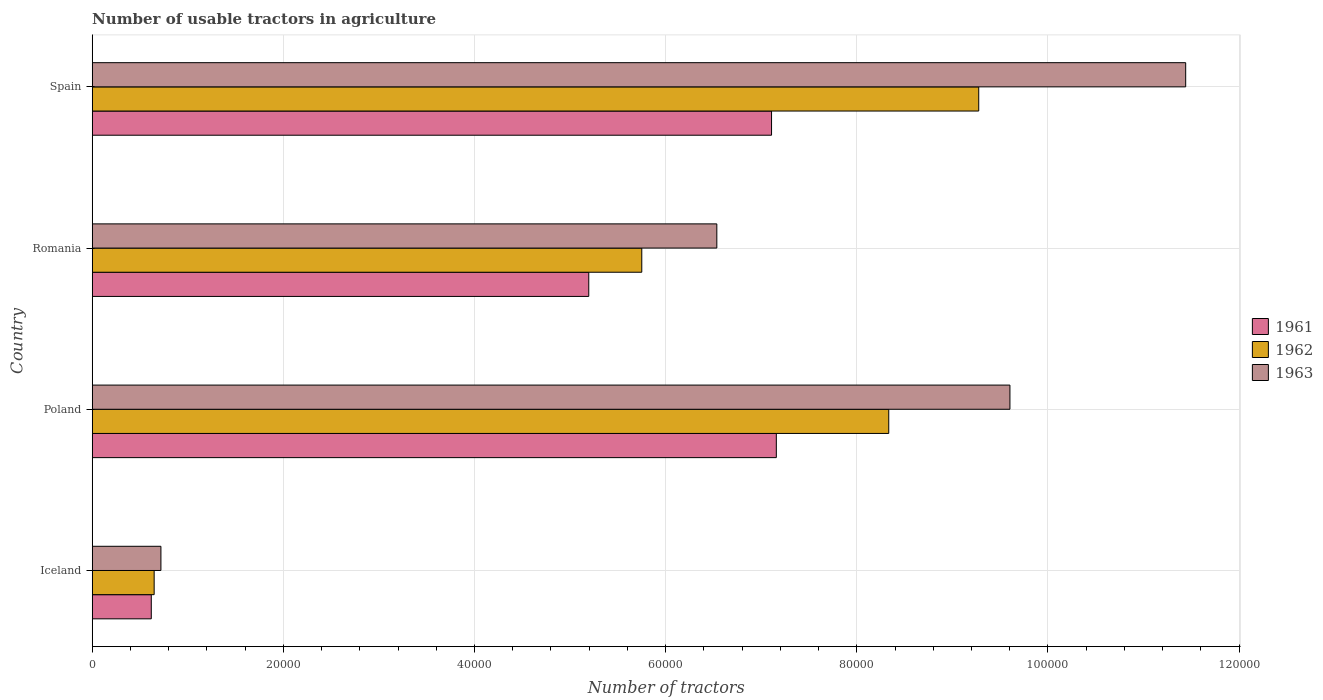Are the number of bars per tick equal to the number of legend labels?
Keep it short and to the point. Yes. How many bars are there on the 4th tick from the bottom?
Your answer should be compact. 3. What is the label of the 4th group of bars from the top?
Give a very brief answer. Iceland. What is the number of usable tractors in agriculture in 1961 in Poland?
Your answer should be very brief. 7.16e+04. Across all countries, what is the maximum number of usable tractors in agriculture in 1961?
Make the answer very short. 7.16e+04. Across all countries, what is the minimum number of usable tractors in agriculture in 1963?
Offer a terse response. 7187. In which country was the number of usable tractors in agriculture in 1961 maximum?
Provide a succinct answer. Poland. What is the total number of usable tractors in agriculture in 1963 in the graph?
Provide a succinct answer. 2.83e+05. What is the difference between the number of usable tractors in agriculture in 1963 in Iceland and that in Poland?
Ensure brevity in your answer.  -8.88e+04. What is the difference between the number of usable tractors in agriculture in 1961 in Romania and the number of usable tractors in agriculture in 1962 in Spain?
Keep it short and to the point. -4.08e+04. What is the average number of usable tractors in agriculture in 1961 per country?
Keep it short and to the point. 5.02e+04. What is the difference between the number of usable tractors in agriculture in 1961 and number of usable tractors in agriculture in 1963 in Romania?
Your answer should be compact. -1.34e+04. What is the ratio of the number of usable tractors in agriculture in 1961 in Poland to that in Spain?
Your response must be concise. 1.01. Is the number of usable tractors in agriculture in 1962 in Romania less than that in Spain?
Make the answer very short. Yes. What is the difference between the highest and the second highest number of usable tractors in agriculture in 1963?
Your answer should be very brief. 1.84e+04. What is the difference between the highest and the lowest number of usable tractors in agriculture in 1961?
Keep it short and to the point. 6.54e+04. Is the sum of the number of usable tractors in agriculture in 1962 in Iceland and Romania greater than the maximum number of usable tractors in agriculture in 1963 across all countries?
Keep it short and to the point. No. What does the 3rd bar from the top in Poland represents?
Your answer should be very brief. 1961. What does the 3rd bar from the bottom in Spain represents?
Provide a succinct answer. 1963. Are all the bars in the graph horizontal?
Offer a very short reply. Yes. How many countries are there in the graph?
Offer a very short reply. 4. What is the difference between two consecutive major ticks on the X-axis?
Provide a short and direct response. 2.00e+04. Are the values on the major ticks of X-axis written in scientific E-notation?
Provide a short and direct response. No. Does the graph contain any zero values?
Keep it short and to the point. No. Does the graph contain grids?
Ensure brevity in your answer.  Yes. How many legend labels are there?
Keep it short and to the point. 3. What is the title of the graph?
Your answer should be very brief. Number of usable tractors in agriculture. Does "1998" appear as one of the legend labels in the graph?
Make the answer very short. No. What is the label or title of the X-axis?
Ensure brevity in your answer.  Number of tractors. What is the Number of tractors in 1961 in Iceland?
Provide a succinct answer. 6177. What is the Number of tractors of 1962 in Iceland?
Ensure brevity in your answer.  6479. What is the Number of tractors of 1963 in Iceland?
Keep it short and to the point. 7187. What is the Number of tractors in 1961 in Poland?
Provide a short and direct response. 7.16e+04. What is the Number of tractors in 1962 in Poland?
Ensure brevity in your answer.  8.33e+04. What is the Number of tractors in 1963 in Poland?
Provide a succinct answer. 9.60e+04. What is the Number of tractors in 1961 in Romania?
Your answer should be compact. 5.20e+04. What is the Number of tractors in 1962 in Romania?
Keep it short and to the point. 5.75e+04. What is the Number of tractors in 1963 in Romania?
Offer a very short reply. 6.54e+04. What is the Number of tractors of 1961 in Spain?
Keep it short and to the point. 7.11e+04. What is the Number of tractors in 1962 in Spain?
Ensure brevity in your answer.  9.28e+04. What is the Number of tractors in 1963 in Spain?
Provide a short and direct response. 1.14e+05. Across all countries, what is the maximum Number of tractors of 1961?
Offer a terse response. 7.16e+04. Across all countries, what is the maximum Number of tractors of 1962?
Your response must be concise. 9.28e+04. Across all countries, what is the maximum Number of tractors in 1963?
Your answer should be very brief. 1.14e+05. Across all countries, what is the minimum Number of tractors of 1961?
Your response must be concise. 6177. Across all countries, what is the minimum Number of tractors of 1962?
Provide a succinct answer. 6479. Across all countries, what is the minimum Number of tractors in 1963?
Keep it short and to the point. 7187. What is the total Number of tractors in 1961 in the graph?
Your answer should be compact. 2.01e+05. What is the total Number of tractors of 1962 in the graph?
Provide a short and direct response. 2.40e+05. What is the total Number of tractors in 1963 in the graph?
Your response must be concise. 2.83e+05. What is the difference between the Number of tractors of 1961 in Iceland and that in Poland?
Offer a terse response. -6.54e+04. What is the difference between the Number of tractors in 1962 in Iceland and that in Poland?
Your answer should be compact. -7.69e+04. What is the difference between the Number of tractors in 1963 in Iceland and that in Poland?
Ensure brevity in your answer.  -8.88e+04. What is the difference between the Number of tractors of 1961 in Iceland and that in Romania?
Ensure brevity in your answer.  -4.58e+04. What is the difference between the Number of tractors in 1962 in Iceland and that in Romania?
Offer a terse response. -5.10e+04. What is the difference between the Number of tractors in 1963 in Iceland and that in Romania?
Offer a terse response. -5.82e+04. What is the difference between the Number of tractors of 1961 in Iceland and that in Spain?
Provide a short and direct response. -6.49e+04. What is the difference between the Number of tractors in 1962 in Iceland and that in Spain?
Your response must be concise. -8.63e+04. What is the difference between the Number of tractors of 1963 in Iceland and that in Spain?
Provide a short and direct response. -1.07e+05. What is the difference between the Number of tractors in 1961 in Poland and that in Romania?
Offer a very short reply. 1.96e+04. What is the difference between the Number of tractors in 1962 in Poland and that in Romania?
Offer a terse response. 2.58e+04. What is the difference between the Number of tractors in 1963 in Poland and that in Romania?
Your response must be concise. 3.07e+04. What is the difference between the Number of tractors of 1961 in Poland and that in Spain?
Provide a succinct answer. 500. What is the difference between the Number of tractors in 1962 in Poland and that in Spain?
Your response must be concise. -9414. What is the difference between the Number of tractors of 1963 in Poland and that in Spain?
Make the answer very short. -1.84e+04. What is the difference between the Number of tractors of 1961 in Romania and that in Spain?
Your answer should be compact. -1.91e+04. What is the difference between the Number of tractors in 1962 in Romania and that in Spain?
Your answer should be very brief. -3.53e+04. What is the difference between the Number of tractors in 1963 in Romania and that in Spain?
Your answer should be compact. -4.91e+04. What is the difference between the Number of tractors of 1961 in Iceland and the Number of tractors of 1962 in Poland?
Provide a succinct answer. -7.72e+04. What is the difference between the Number of tractors of 1961 in Iceland and the Number of tractors of 1963 in Poland?
Ensure brevity in your answer.  -8.98e+04. What is the difference between the Number of tractors in 1962 in Iceland and the Number of tractors in 1963 in Poland?
Your answer should be very brief. -8.95e+04. What is the difference between the Number of tractors in 1961 in Iceland and the Number of tractors in 1962 in Romania?
Your answer should be very brief. -5.13e+04. What is the difference between the Number of tractors of 1961 in Iceland and the Number of tractors of 1963 in Romania?
Provide a succinct answer. -5.92e+04. What is the difference between the Number of tractors in 1962 in Iceland and the Number of tractors in 1963 in Romania?
Keep it short and to the point. -5.89e+04. What is the difference between the Number of tractors of 1961 in Iceland and the Number of tractors of 1962 in Spain?
Your answer should be very brief. -8.66e+04. What is the difference between the Number of tractors in 1961 in Iceland and the Number of tractors in 1963 in Spain?
Provide a succinct answer. -1.08e+05. What is the difference between the Number of tractors of 1962 in Iceland and the Number of tractors of 1963 in Spain?
Provide a succinct answer. -1.08e+05. What is the difference between the Number of tractors of 1961 in Poland and the Number of tractors of 1962 in Romania?
Offer a terse response. 1.41e+04. What is the difference between the Number of tractors of 1961 in Poland and the Number of tractors of 1963 in Romania?
Offer a terse response. 6226. What is the difference between the Number of tractors in 1962 in Poland and the Number of tractors in 1963 in Romania?
Ensure brevity in your answer.  1.80e+04. What is the difference between the Number of tractors of 1961 in Poland and the Number of tractors of 1962 in Spain?
Provide a succinct answer. -2.12e+04. What is the difference between the Number of tractors of 1961 in Poland and the Number of tractors of 1963 in Spain?
Your answer should be very brief. -4.28e+04. What is the difference between the Number of tractors in 1962 in Poland and the Number of tractors in 1963 in Spain?
Your response must be concise. -3.11e+04. What is the difference between the Number of tractors in 1961 in Romania and the Number of tractors in 1962 in Spain?
Your answer should be compact. -4.08e+04. What is the difference between the Number of tractors in 1961 in Romania and the Number of tractors in 1963 in Spain?
Your response must be concise. -6.25e+04. What is the difference between the Number of tractors of 1962 in Romania and the Number of tractors of 1963 in Spain?
Your answer should be compact. -5.69e+04. What is the average Number of tractors of 1961 per country?
Ensure brevity in your answer.  5.02e+04. What is the average Number of tractors in 1962 per country?
Keep it short and to the point. 6.00e+04. What is the average Number of tractors of 1963 per country?
Provide a succinct answer. 7.07e+04. What is the difference between the Number of tractors in 1961 and Number of tractors in 1962 in Iceland?
Provide a succinct answer. -302. What is the difference between the Number of tractors of 1961 and Number of tractors of 1963 in Iceland?
Ensure brevity in your answer.  -1010. What is the difference between the Number of tractors in 1962 and Number of tractors in 1963 in Iceland?
Your answer should be compact. -708. What is the difference between the Number of tractors of 1961 and Number of tractors of 1962 in Poland?
Give a very brief answer. -1.18e+04. What is the difference between the Number of tractors of 1961 and Number of tractors of 1963 in Poland?
Offer a very short reply. -2.44e+04. What is the difference between the Number of tractors in 1962 and Number of tractors in 1963 in Poland?
Make the answer very short. -1.27e+04. What is the difference between the Number of tractors in 1961 and Number of tractors in 1962 in Romania?
Your answer should be compact. -5548. What is the difference between the Number of tractors of 1961 and Number of tractors of 1963 in Romania?
Your answer should be very brief. -1.34e+04. What is the difference between the Number of tractors of 1962 and Number of tractors of 1963 in Romania?
Ensure brevity in your answer.  -7851. What is the difference between the Number of tractors of 1961 and Number of tractors of 1962 in Spain?
Your answer should be compact. -2.17e+04. What is the difference between the Number of tractors of 1961 and Number of tractors of 1963 in Spain?
Ensure brevity in your answer.  -4.33e+04. What is the difference between the Number of tractors of 1962 and Number of tractors of 1963 in Spain?
Your answer should be compact. -2.17e+04. What is the ratio of the Number of tractors of 1961 in Iceland to that in Poland?
Your answer should be very brief. 0.09. What is the ratio of the Number of tractors in 1962 in Iceland to that in Poland?
Provide a succinct answer. 0.08. What is the ratio of the Number of tractors in 1963 in Iceland to that in Poland?
Make the answer very short. 0.07. What is the ratio of the Number of tractors in 1961 in Iceland to that in Romania?
Your answer should be very brief. 0.12. What is the ratio of the Number of tractors in 1962 in Iceland to that in Romania?
Make the answer very short. 0.11. What is the ratio of the Number of tractors of 1963 in Iceland to that in Romania?
Provide a short and direct response. 0.11. What is the ratio of the Number of tractors in 1961 in Iceland to that in Spain?
Your answer should be very brief. 0.09. What is the ratio of the Number of tractors of 1962 in Iceland to that in Spain?
Your response must be concise. 0.07. What is the ratio of the Number of tractors in 1963 in Iceland to that in Spain?
Give a very brief answer. 0.06. What is the ratio of the Number of tractors in 1961 in Poland to that in Romania?
Provide a succinct answer. 1.38. What is the ratio of the Number of tractors of 1962 in Poland to that in Romania?
Your answer should be compact. 1.45. What is the ratio of the Number of tractors of 1963 in Poland to that in Romania?
Offer a terse response. 1.47. What is the ratio of the Number of tractors of 1962 in Poland to that in Spain?
Offer a terse response. 0.9. What is the ratio of the Number of tractors of 1963 in Poland to that in Spain?
Your answer should be very brief. 0.84. What is the ratio of the Number of tractors in 1961 in Romania to that in Spain?
Offer a very short reply. 0.73. What is the ratio of the Number of tractors of 1962 in Romania to that in Spain?
Ensure brevity in your answer.  0.62. What is the ratio of the Number of tractors of 1963 in Romania to that in Spain?
Your answer should be very brief. 0.57. What is the difference between the highest and the second highest Number of tractors of 1961?
Your answer should be compact. 500. What is the difference between the highest and the second highest Number of tractors in 1962?
Ensure brevity in your answer.  9414. What is the difference between the highest and the second highest Number of tractors in 1963?
Your answer should be very brief. 1.84e+04. What is the difference between the highest and the lowest Number of tractors in 1961?
Give a very brief answer. 6.54e+04. What is the difference between the highest and the lowest Number of tractors in 1962?
Make the answer very short. 8.63e+04. What is the difference between the highest and the lowest Number of tractors in 1963?
Offer a terse response. 1.07e+05. 